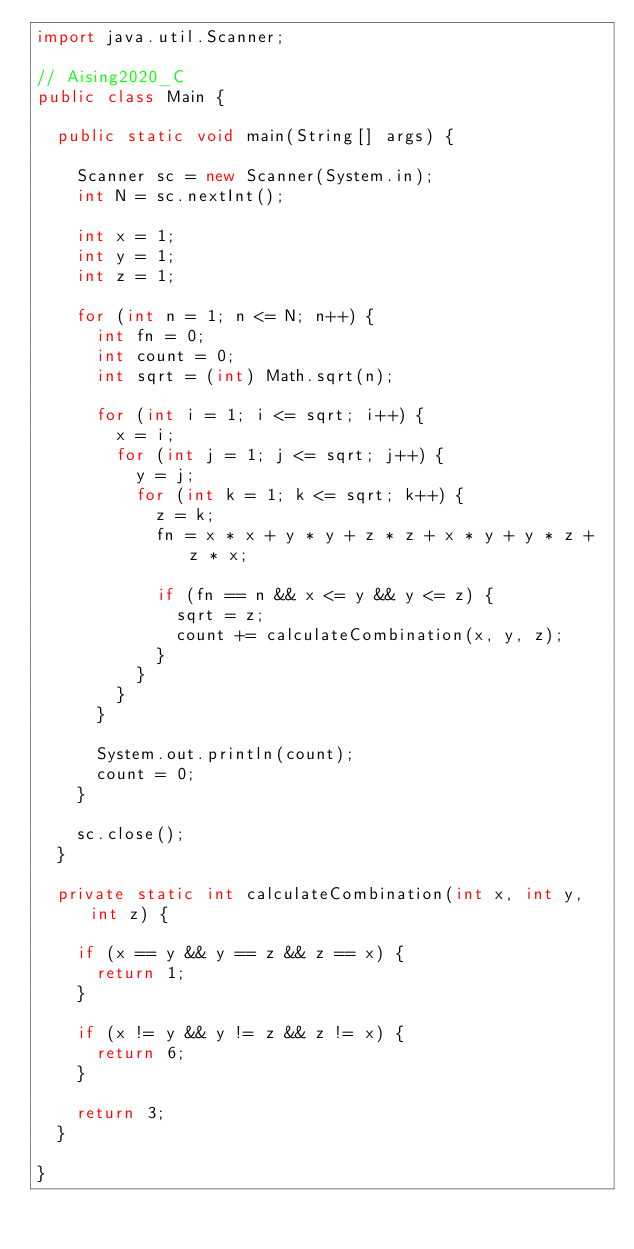<code> <loc_0><loc_0><loc_500><loc_500><_Java_>import java.util.Scanner;

// Aising2020_C
public class Main {

	public static void main(String[] args) {

		Scanner sc = new Scanner(System.in);
		int N = sc.nextInt();

		int x = 1;
		int y = 1;
		int z = 1;

		for (int n = 1; n <= N; n++) {
			int fn = 0;
			int count = 0;
			int sqrt = (int) Math.sqrt(n);

			for (int i = 1; i <= sqrt; i++) {
				x = i;
				for (int j = 1; j <= sqrt; j++) {
					y = j;
					for (int k = 1; k <= sqrt; k++) {
						z = k;
						fn = x * x + y * y + z * z + x * y + y * z + z * x;

						if (fn == n && x <= y && y <= z) {
							sqrt = z;
							count += calculateCombination(x, y, z);
						}
					}
				}
			}

			System.out.println(count);
			count = 0;
		}

		sc.close();
	}

	private static int calculateCombination(int x, int y, int z) {

		if (x == y && y == z && z == x) {
			return 1;
		}

		if (x != y && y != z && z != x) {
			return 6;
		}

		return 3;
	}

}
</code> 